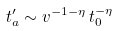Convert formula to latex. <formula><loc_0><loc_0><loc_500><loc_500>t _ { a } ^ { \prime } \sim v ^ { - 1 - \eta } \, t _ { 0 } ^ { - \eta } \,</formula> 